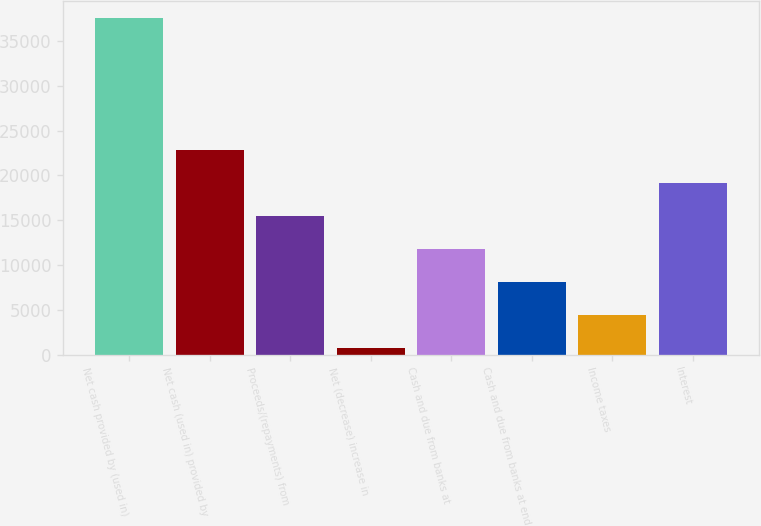Convert chart to OTSL. <chart><loc_0><loc_0><loc_500><loc_500><bar_chart><fcel>Net cash provided by (used in)<fcel>Net cash (used in) provided by<fcel>Proceeds/(repayments) from<fcel>Net (decrease) increase in<fcel>Cash and due from banks at<fcel>Cash and due from banks at end<fcel>Income taxes<fcel>Interest<nl><fcel>37603<fcel>22857.8<fcel>15485.2<fcel>740<fcel>11798.9<fcel>8112.6<fcel>4426.3<fcel>19171.5<nl></chart> 